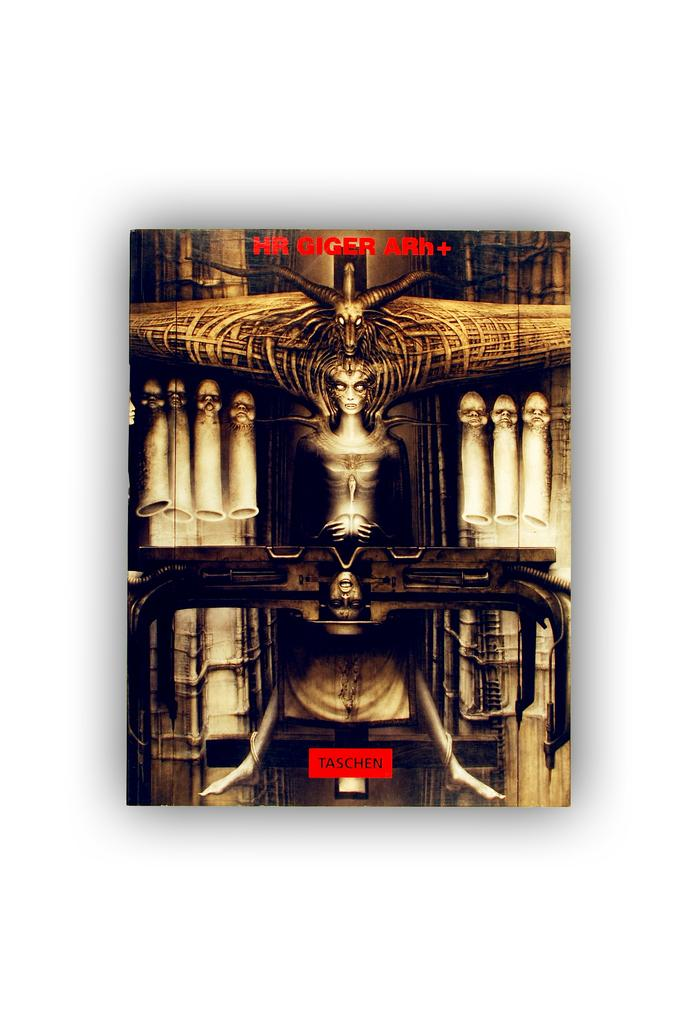<image>
Write a terse but informative summary of the picture. Cover showing some religious pictures and the word "Taschen" on the bottom. 